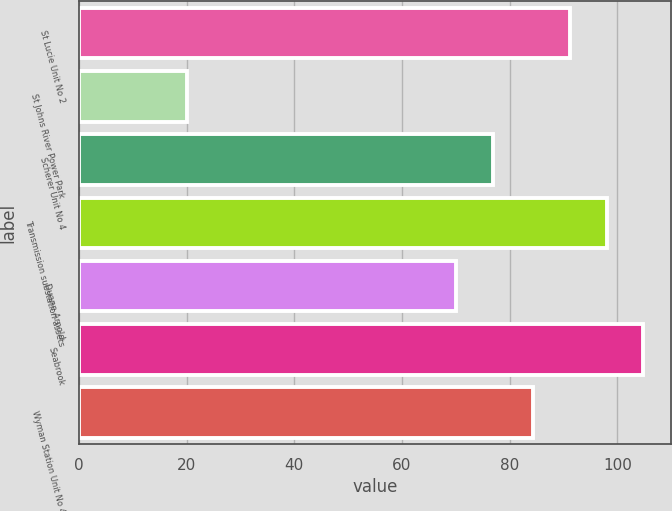Convert chart to OTSL. <chart><loc_0><loc_0><loc_500><loc_500><bar_chart><fcel>St Lucie Unit No 2<fcel>St Johns River Power Park<fcel>Scherer Unit No 4<fcel>Transmission substation assets<fcel>Duane Arnold<fcel>Seabrook<fcel>Wyman Station Unit No 4<nl><fcel>91.17<fcel>20<fcel>76.82<fcel>97.99<fcel>70<fcel>104.81<fcel>84.35<nl></chart> 